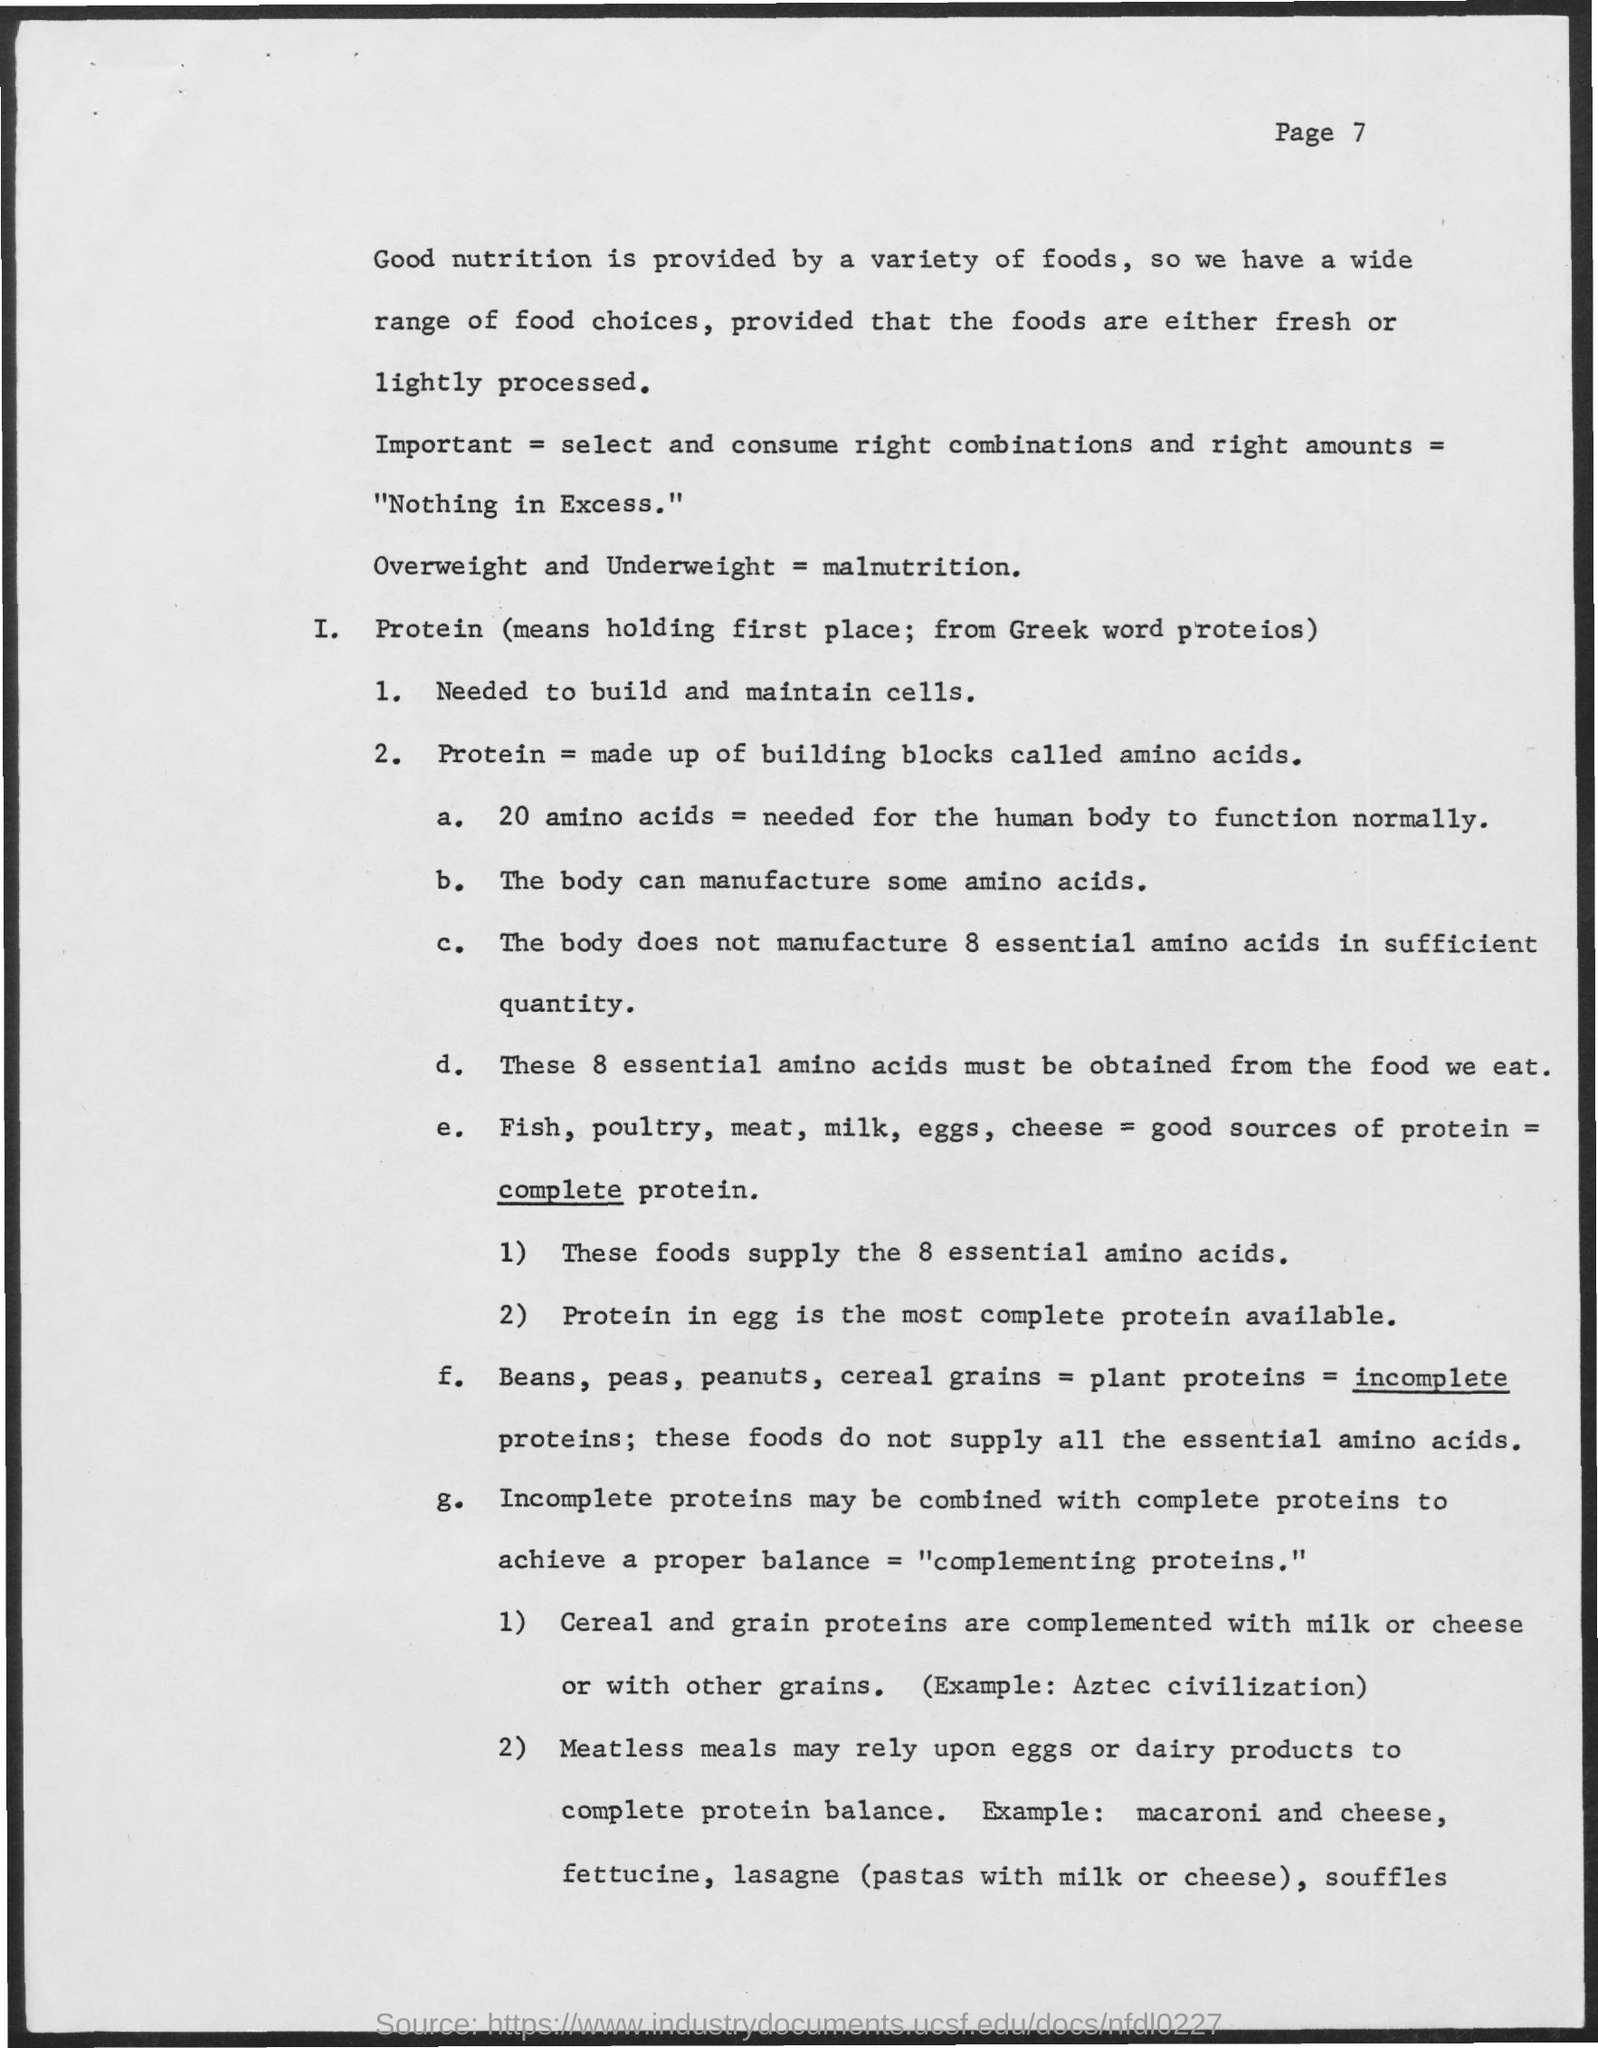What is the need of proteins ?
Offer a terse response. NEEDED TO BUILD AND MAINTAIN CELLS. Which proteins are called as incomplete proteins ?
Your answer should be very brief. Plant proteins. 